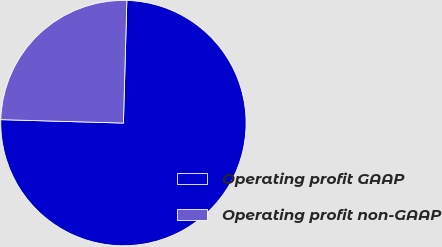Convert chart to OTSL. <chart><loc_0><loc_0><loc_500><loc_500><pie_chart><fcel>Operating profit GAAP<fcel>Operating profit non-GAAP<nl><fcel>75.0%<fcel>25.0%<nl></chart> 